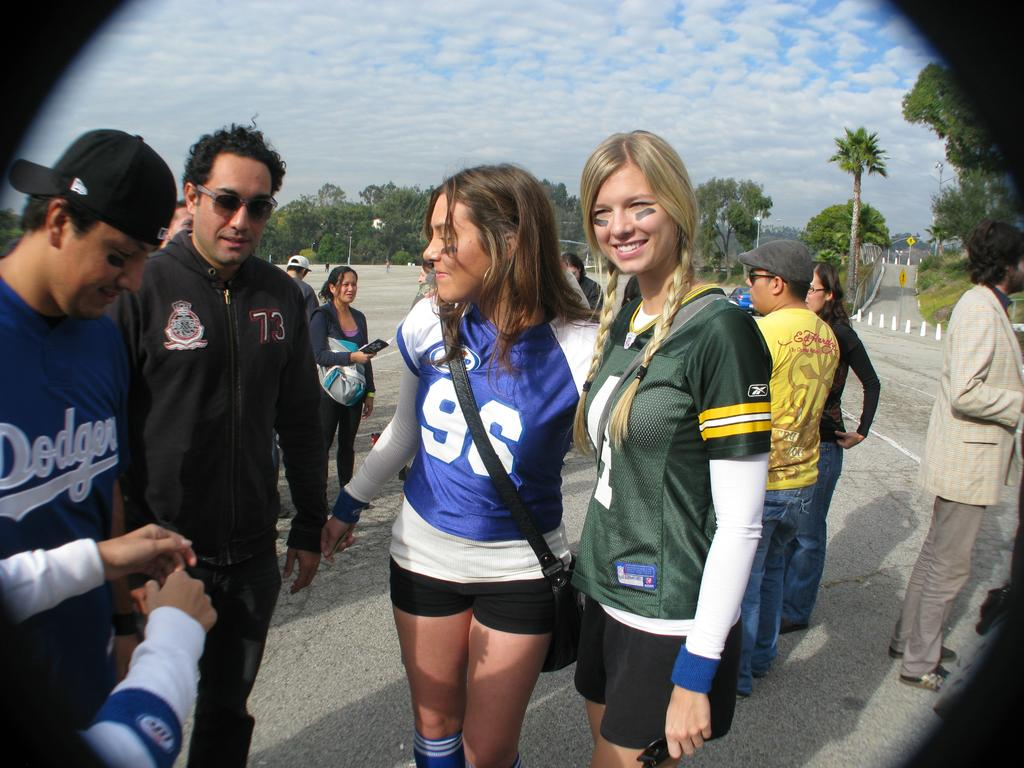<image>
Share a concise interpretation of the image provided. A man with a blue Dodgers shirt talks with another man and 2 women wearing jerseys. 